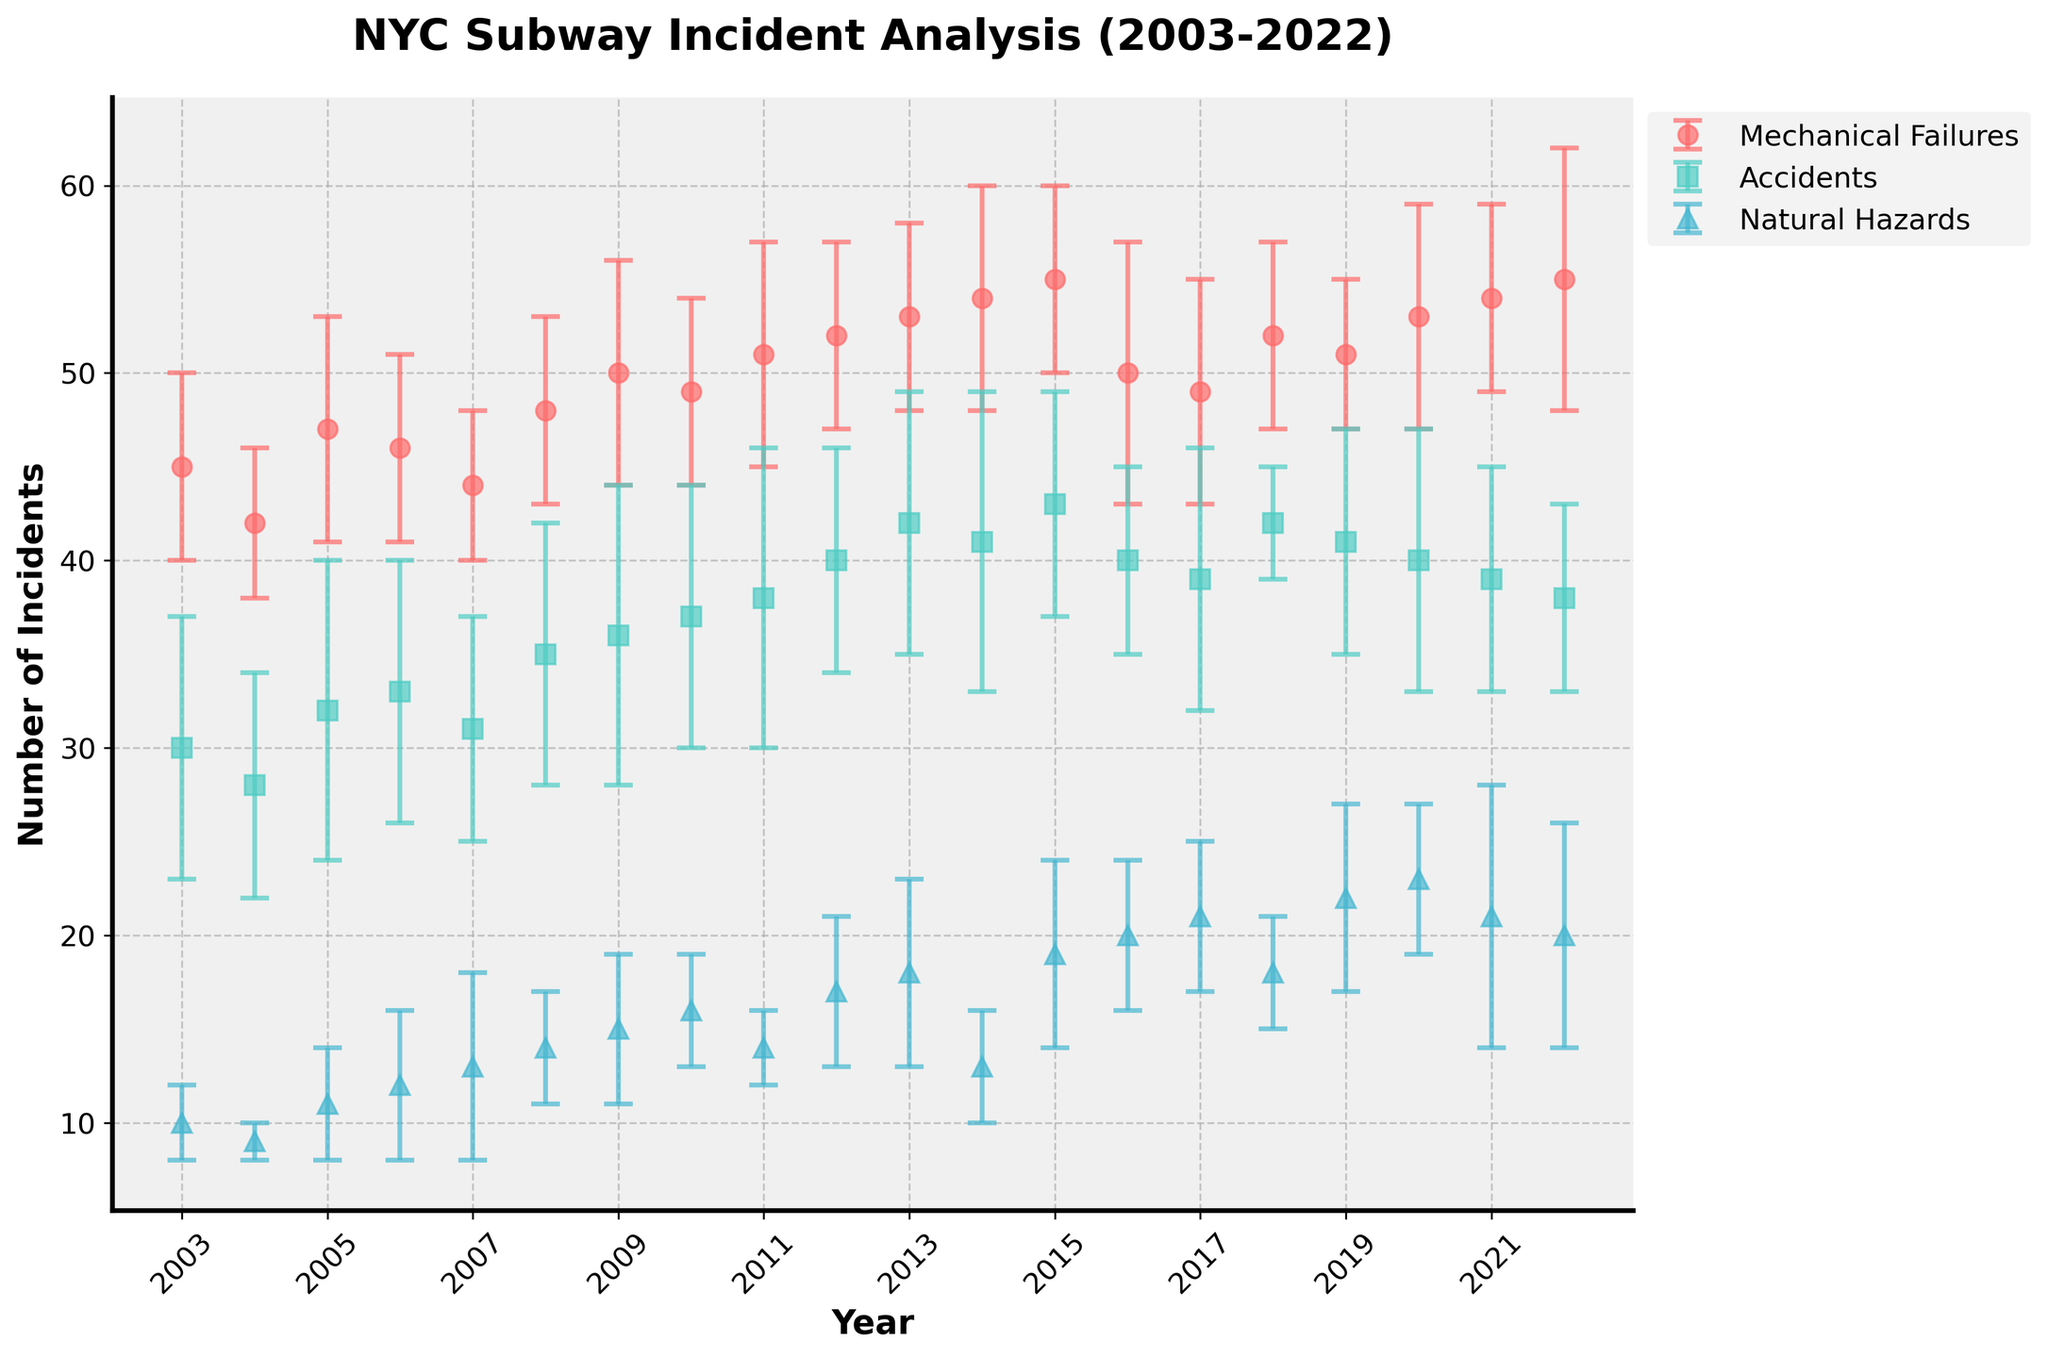what is the title of the figure? The title of the figure is written at the top of the plot and is commonly used to describe the main subject of the graph. By looking at the top center of the plot, one can see that the title displayed is "NYC Subway Incident Analysis (2003-2022)."
Answer: "NYC Subway Incident Analysis (2003-2022)" How does the number of mechanical failures in 2003 compare to 2013? To compare the number of mechanical failures in these two years, look at their respective points and error bars in the figure. In 2003, the number of mechanical failures is 45, and in 2013, it is 53. So, the number of mechanical failures increased by 8 from 2003 to 2013.
Answer: The number increased by 8 Which incident type had the highest number of incidents in 2016? To identify this, observe the different data points in 2016 for mechanical failures, accidents, and natural hazards. Mechanical failures had 50 incidents, accidents had 40, and natural hazards had 20 incidents. Thus, mechanical failures had the highest number of incidents in 2016.
Answer: Mechanical Failures What is the overall trend of natural hazards incidents from 2003 to 2022? Observing the plot, natural hazards incidents show an overall increasing trend from 2003 to 2022. Starting from 10 incidents in 2003 and reaching 20 incidents in 2022, although with some fluctuations along the way.
Answer: Increasing trend In which year did accidents report the highest number of incidents? We need to look across the data points labeled for accidents. The highest point for accidents is in 2013, where the number of incidents is 42.
Answer: 2013 Calculate the average number of mechanical failures between 2017 and 2022. We take the values for mechanical failures from 2017 to 2022 (49, 52, 51, 53, 54, 55) and calculate the average: (49 + 52 + 51 + 53 + 54 + 55) / 6 = 314 / 6 = 52.33.
Answer: 52.33 Which type of incident shows the least stability in reported numbers, indicated by larger error bars, over the years? Examining the error bars on the plot, accidents generally seem to have larger error bars compared to mechanical failures and natural hazards, indicating less stability in the number of incidents reported.
Answer: Accidents How many years had the counts for accidents decreased compared to the previous year? By scanning through each year's data point for accidents, notice that the numbers decrease in the years 2004, 2007, 2016, 2017, 2019, 2020, and 2021. This gives us a total of 7 years.
Answer: 7 years 